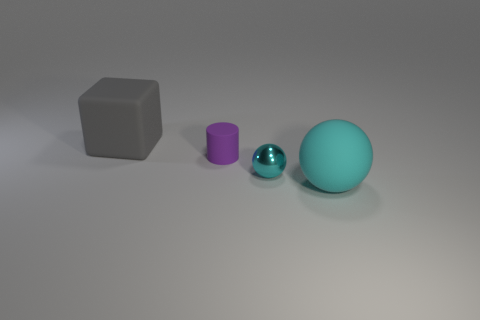How many objects are purple rubber cylinders or big gray cubes?
Your answer should be compact. 2. There is a big matte object that is in front of the large matte thing left of the large rubber thing that is in front of the tiny purple object; what is its shape?
Make the answer very short. Sphere. Is the large thing in front of the big gray matte object made of the same material as the small object that is on the left side of the small cyan metallic sphere?
Your answer should be very brief. Yes. There is another object that is the same shape as the tiny cyan shiny object; what material is it?
Provide a succinct answer. Rubber. Are there any other things that have the same size as the metal thing?
Give a very brief answer. Yes. Is the shape of the cyan object left of the big matte ball the same as the large rubber object right of the large gray object?
Ensure brevity in your answer.  Yes. Are there fewer matte cylinders to the right of the purple rubber cylinder than balls that are behind the gray object?
Offer a very short reply. No. What number of other things are there of the same shape as the tiny cyan metal thing?
Ensure brevity in your answer.  1. There is a cyan object that is made of the same material as the gray object; what is its shape?
Provide a succinct answer. Sphere. What color is the thing that is both in front of the gray rubber cube and left of the metal ball?
Make the answer very short. Purple. 